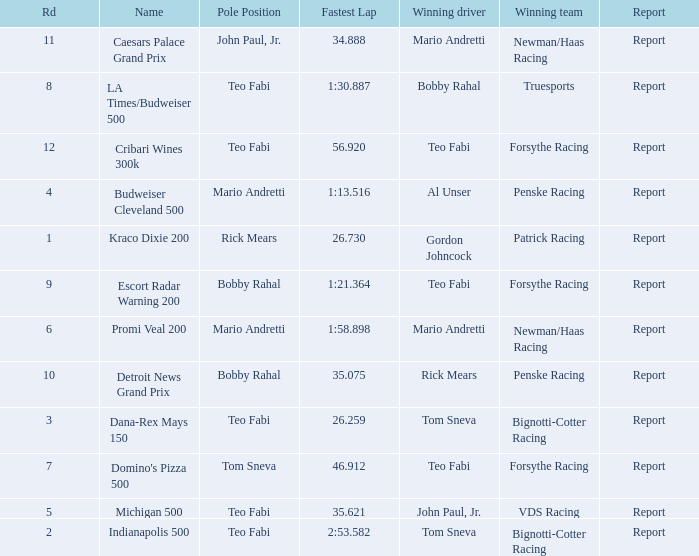What was the fastest lap time in the Escort Radar Warning 200? 1:21.364. 